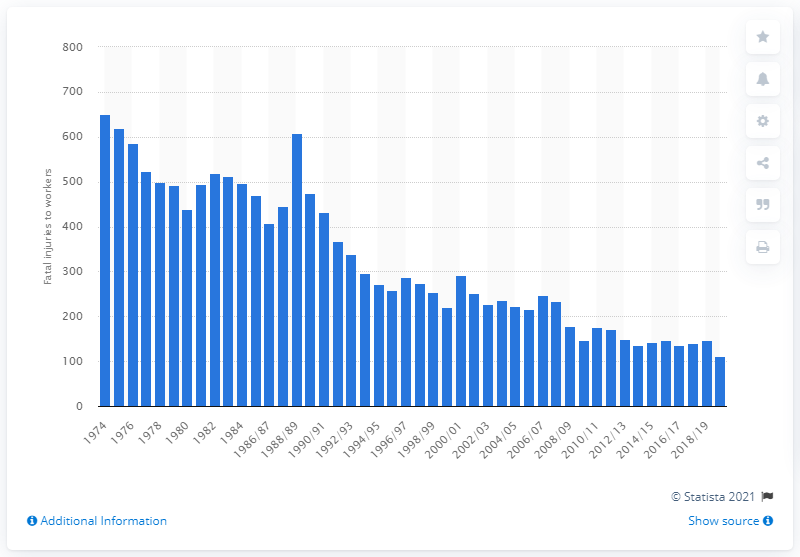Highlight a few significant elements in this photo. In the year 2019/20, 111 workers lost their lives in Great Britain. 